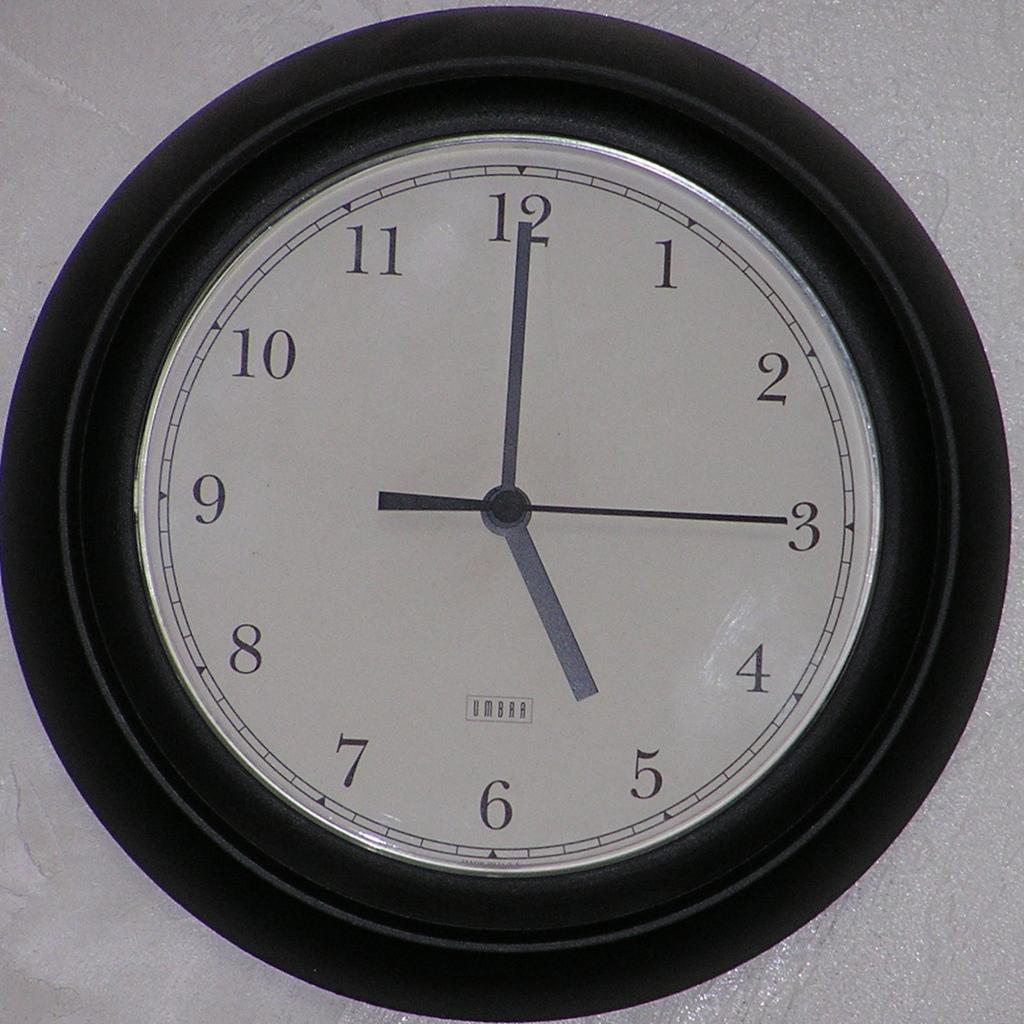Provide a one-sentence caption for the provided image. The image displays black and white, circular, analog clock with the time 5:00 displayed. 